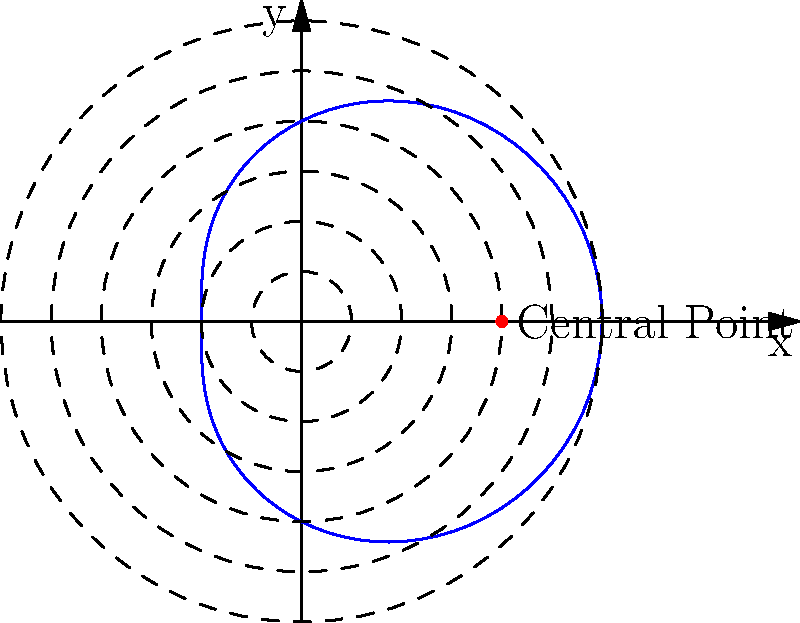In tracking a local flu outbreak, you've determined that the spread from a central point can be modeled using polar coordinates with the equation $r = 2 + \cos(\theta)$, where $r$ is in miles. What is the maximum distance (in miles) from the central point that the flu has spread? To find the maximum distance the flu has spread, we need to determine the maximum value of $r$ in the given polar equation.

1. The equation is given as $r = 2 + \cos(\theta)$

2. We know that the cosine function oscillates between -1 and 1.

3. The maximum value of $\cos(\theta)$ is 1.

4. Therefore, the maximum value of $r$ will occur when $\cos(\theta) = 1$:

   $r_{max} = 2 + 1 = 3$

5. This means that at its farthest point, the flu has spread 3 miles from the central point.

The graph shows this visually, where the blue curve (representing the spread of the flu) touches the outermost dashed circle, which has a radius of 3 units (miles in this case).
Answer: 3 miles 